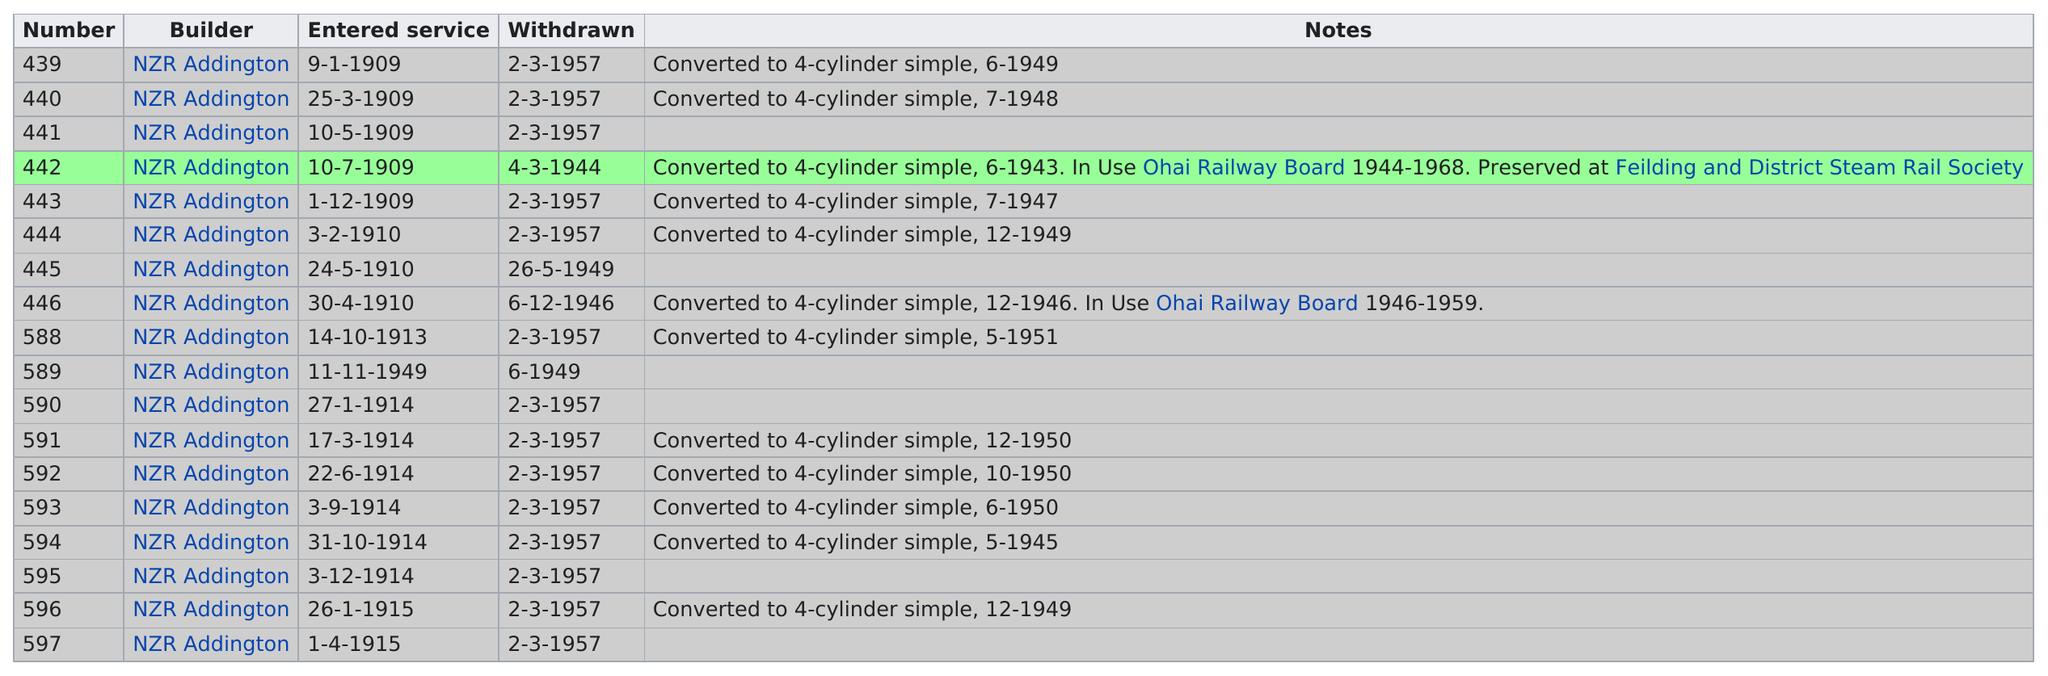Point out several critical features in this image. Twelve of these locomotives were eventually converted to 4-cylinder simple engines. In the same year that 445 was withdrawn from service, another locomotive, numbered 589, was also withdrawn from service. The number that was in service for the least amount of time is 589. On September 1, 1909, please locate the top entered service. The locomotive number 442 was the only one to be withdrawn from service before the year 1945. 